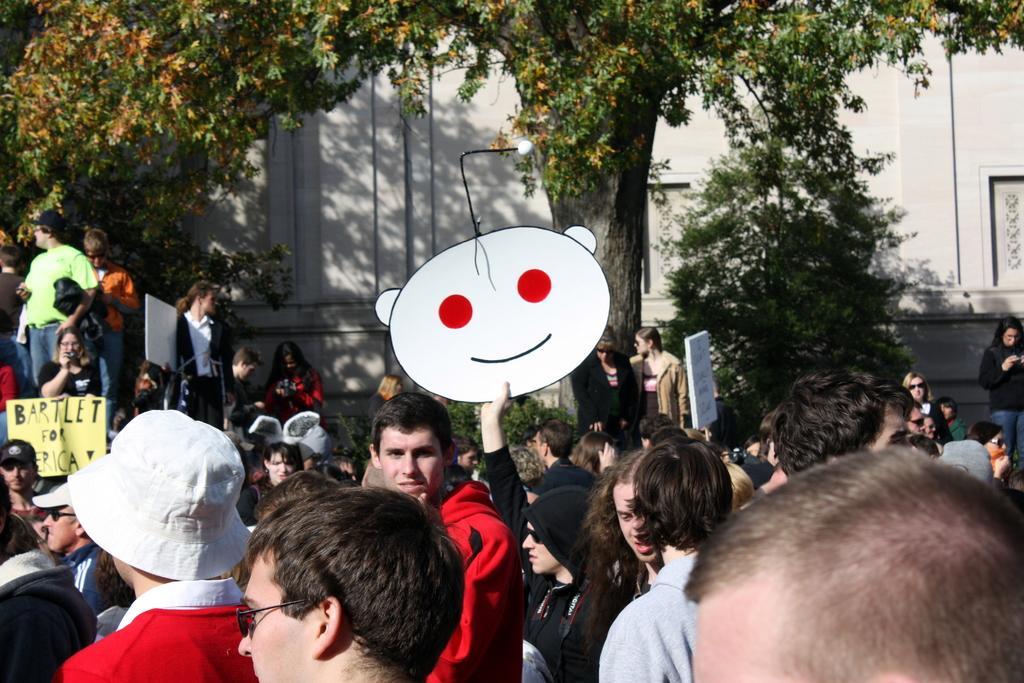Could you give a brief overview of what you see in this image? In the center of the image we can see a person is holding a board. At the bottom of the image we can see a group of people are standing and some of them are wearing the caps. In the background of the image we can see the wall, trees. On the left side of the image we can see some people are standing and holding the boards. 